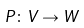Convert formula to latex. <formula><loc_0><loc_0><loc_500><loc_500>P \colon V \to W</formula> 